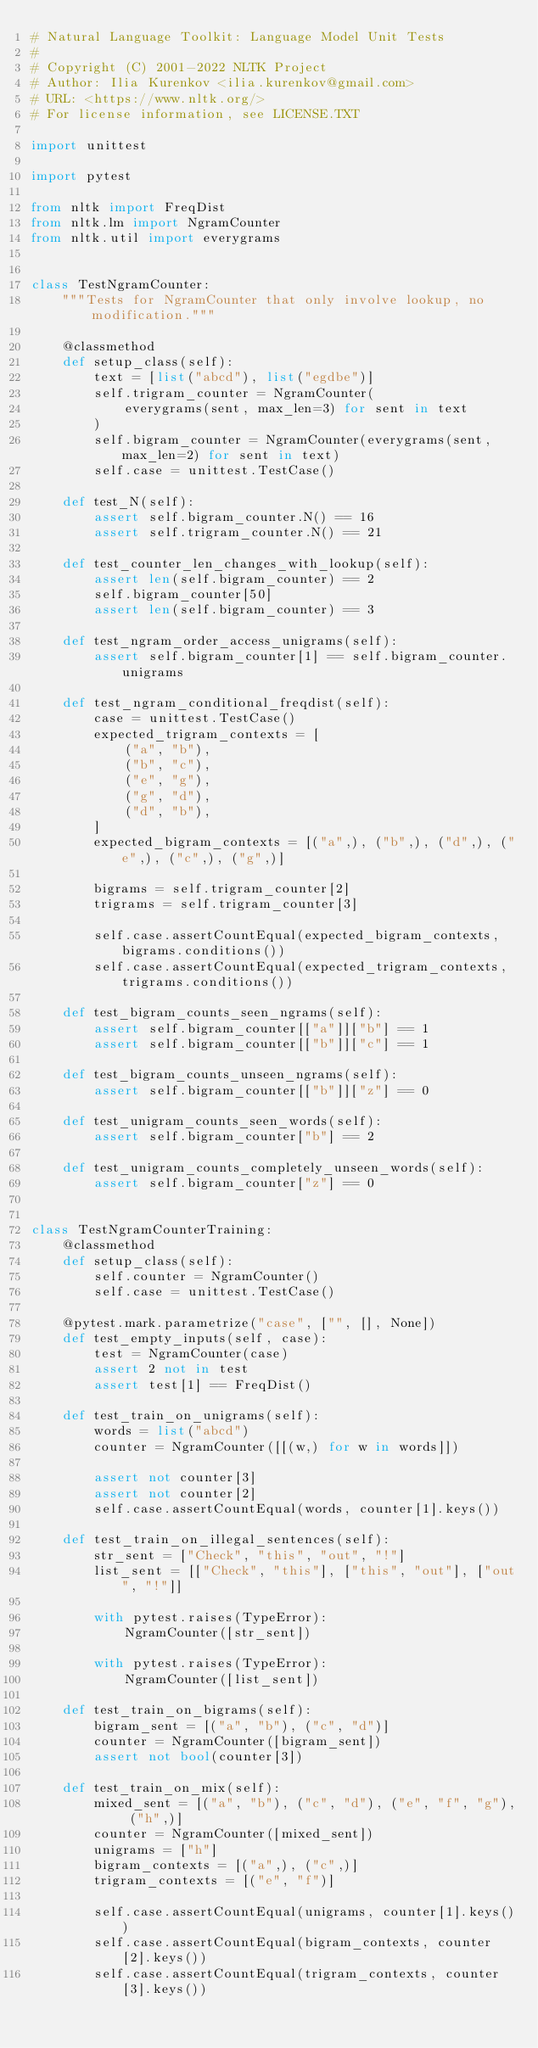<code> <loc_0><loc_0><loc_500><loc_500><_Python_># Natural Language Toolkit: Language Model Unit Tests
#
# Copyright (C) 2001-2022 NLTK Project
# Author: Ilia Kurenkov <ilia.kurenkov@gmail.com>
# URL: <https://www.nltk.org/>
# For license information, see LICENSE.TXT

import unittest

import pytest

from nltk import FreqDist
from nltk.lm import NgramCounter
from nltk.util import everygrams


class TestNgramCounter:
    """Tests for NgramCounter that only involve lookup, no modification."""

    @classmethod
    def setup_class(self):
        text = [list("abcd"), list("egdbe")]
        self.trigram_counter = NgramCounter(
            everygrams(sent, max_len=3) for sent in text
        )
        self.bigram_counter = NgramCounter(everygrams(sent, max_len=2) for sent in text)
        self.case = unittest.TestCase()

    def test_N(self):
        assert self.bigram_counter.N() == 16
        assert self.trigram_counter.N() == 21

    def test_counter_len_changes_with_lookup(self):
        assert len(self.bigram_counter) == 2
        self.bigram_counter[50]
        assert len(self.bigram_counter) == 3

    def test_ngram_order_access_unigrams(self):
        assert self.bigram_counter[1] == self.bigram_counter.unigrams

    def test_ngram_conditional_freqdist(self):
        case = unittest.TestCase()
        expected_trigram_contexts = [
            ("a", "b"),
            ("b", "c"),
            ("e", "g"),
            ("g", "d"),
            ("d", "b"),
        ]
        expected_bigram_contexts = [("a",), ("b",), ("d",), ("e",), ("c",), ("g",)]

        bigrams = self.trigram_counter[2]
        trigrams = self.trigram_counter[3]

        self.case.assertCountEqual(expected_bigram_contexts, bigrams.conditions())
        self.case.assertCountEqual(expected_trigram_contexts, trigrams.conditions())

    def test_bigram_counts_seen_ngrams(self):
        assert self.bigram_counter[["a"]]["b"] == 1
        assert self.bigram_counter[["b"]]["c"] == 1

    def test_bigram_counts_unseen_ngrams(self):
        assert self.bigram_counter[["b"]]["z"] == 0

    def test_unigram_counts_seen_words(self):
        assert self.bigram_counter["b"] == 2

    def test_unigram_counts_completely_unseen_words(self):
        assert self.bigram_counter["z"] == 0


class TestNgramCounterTraining:
    @classmethod
    def setup_class(self):
        self.counter = NgramCounter()
        self.case = unittest.TestCase()

    @pytest.mark.parametrize("case", ["", [], None])
    def test_empty_inputs(self, case):
        test = NgramCounter(case)
        assert 2 not in test
        assert test[1] == FreqDist()

    def test_train_on_unigrams(self):
        words = list("abcd")
        counter = NgramCounter([[(w,) for w in words]])

        assert not counter[3]
        assert not counter[2]
        self.case.assertCountEqual(words, counter[1].keys())

    def test_train_on_illegal_sentences(self):
        str_sent = ["Check", "this", "out", "!"]
        list_sent = [["Check", "this"], ["this", "out"], ["out", "!"]]

        with pytest.raises(TypeError):
            NgramCounter([str_sent])

        with pytest.raises(TypeError):
            NgramCounter([list_sent])

    def test_train_on_bigrams(self):
        bigram_sent = [("a", "b"), ("c", "d")]
        counter = NgramCounter([bigram_sent])
        assert not bool(counter[3])

    def test_train_on_mix(self):
        mixed_sent = [("a", "b"), ("c", "d"), ("e", "f", "g"), ("h",)]
        counter = NgramCounter([mixed_sent])
        unigrams = ["h"]
        bigram_contexts = [("a",), ("c",)]
        trigram_contexts = [("e", "f")]

        self.case.assertCountEqual(unigrams, counter[1].keys())
        self.case.assertCountEqual(bigram_contexts, counter[2].keys())
        self.case.assertCountEqual(trigram_contexts, counter[3].keys())
</code> 